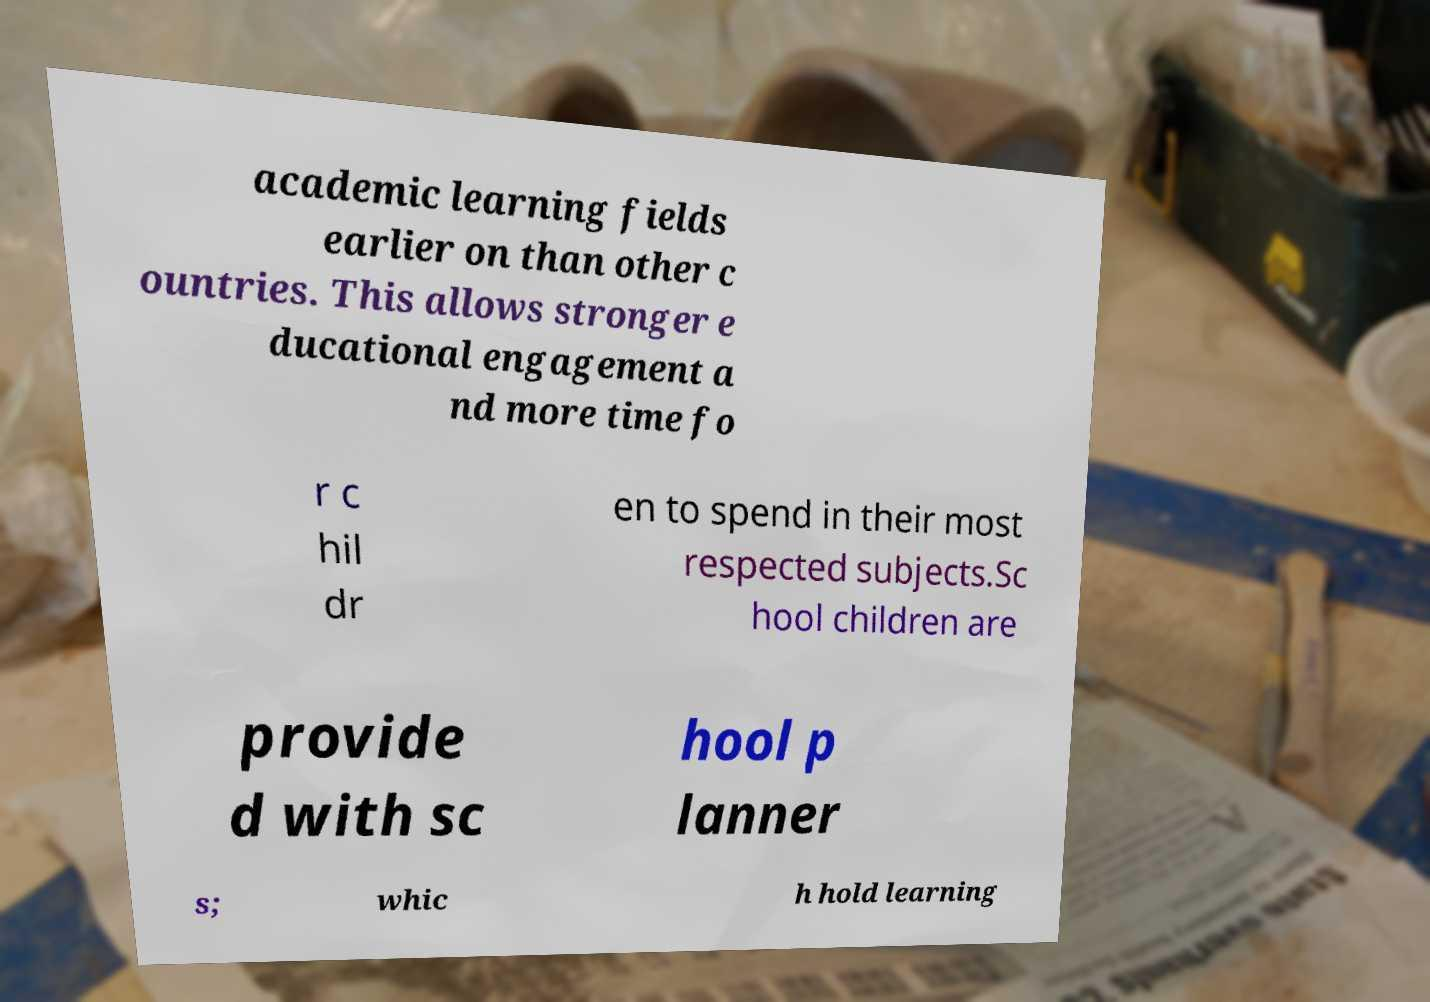Please read and relay the text visible in this image. What does it say? academic learning fields earlier on than other c ountries. This allows stronger e ducational engagement a nd more time fo r c hil dr en to spend in their most respected subjects.Sc hool children are provide d with sc hool p lanner s; whic h hold learning 